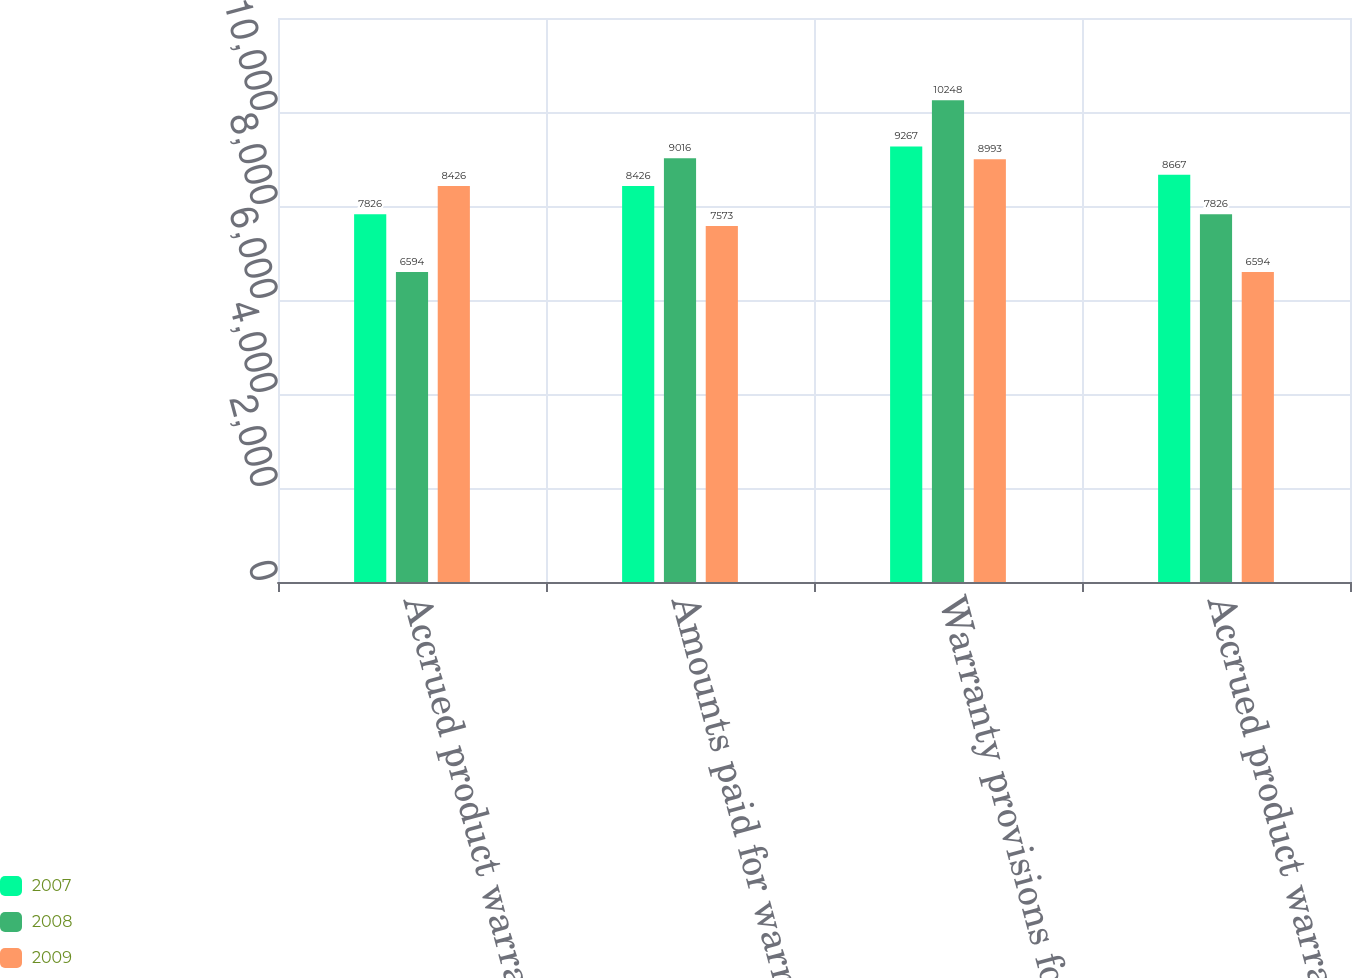Convert chart to OTSL. <chart><loc_0><loc_0><loc_500><loc_500><stacked_bar_chart><ecel><fcel>Accrued product warranties<fcel>Amounts paid for warranty<fcel>Warranty provisions for<fcel>Accrued product warranties end<nl><fcel>2007<fcel>7826<fcel>8426<fcel>9267<fcel>8667<nl><fcel>2008<fcel>6594<fcel>9016<fcel>10248<fcel>7826<nl><fcel>2009<fcel>8426<fcel>7573<fcel>8993<fcel>6594<nl></chart> 